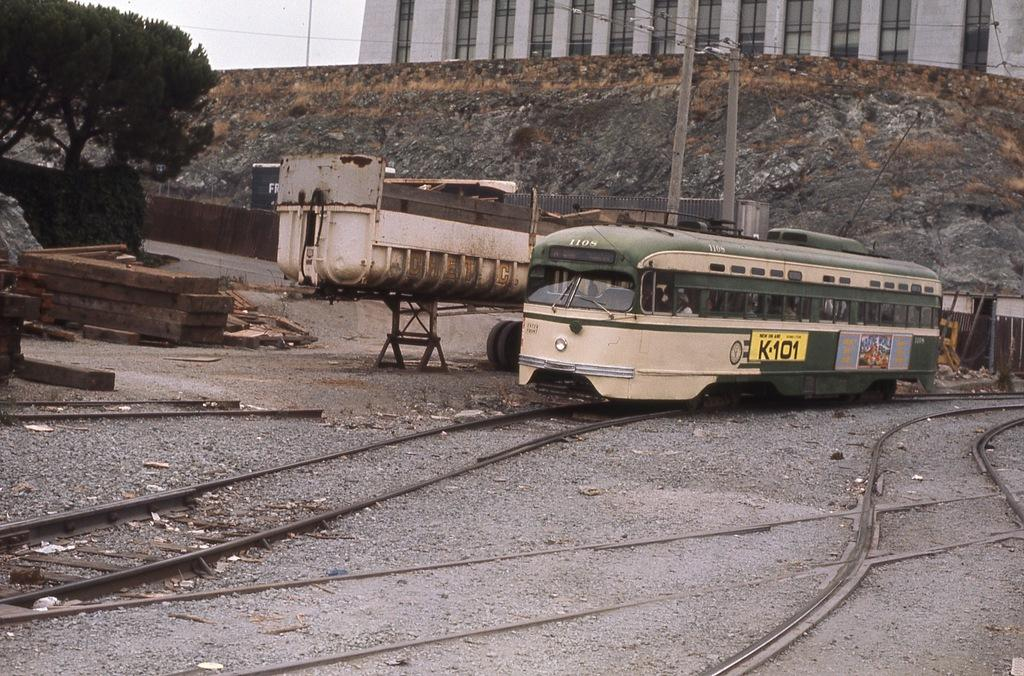<image>
Create a compact narrative representing the image presented. A disused railway yard with an old green and cream tramcar with the number 1108. 